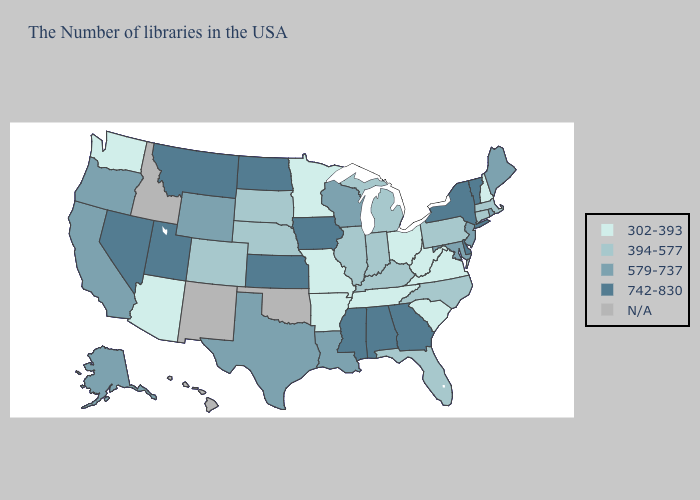Does the map have missing data?
Concise answer only. Yes. Among the states that border Kansas , does Missouri have the highest value?
Keep it brief. No. What is the value of Colorado?
Quick response, please. 394-577. What is the highest value in states that border New Mexico?
Write a very short answer. 742-830. Does Missouri have the highest value in the USA?
Be succinct. No. Does Iowa have the highest value in the USA?
Answer briefly. Yes. Name the states that have a value in the range 394-577?
Keep it brief. Massachusetts, Connecticut, Pennsylvania, North Carolina, Florida, Michigan, Kentucky, Indiana, Illinois, Nebraska, South Dakota, Colorado. What is the value of South Carolina?
Give a very brief answer. 302-393. Among the states that border Wyoming , which have the highest value?
Give a very brief answer. Utah, Montana. Name the states that have a value in the range N/A?
Short answer required. Oklahoma, New Mexico, Idaho, Hawaii. Which states have the lowest value in the Northeast?
Write a very short answer. New Hampshire. What is the value of Wisconsin?
Keep it brief. 579-737. What is the value of Wisconsin?
Quick response, please. 579-737. Among the states that border Florida , which have the lowest value?
Answer briefly. Georgia, Alabama. 